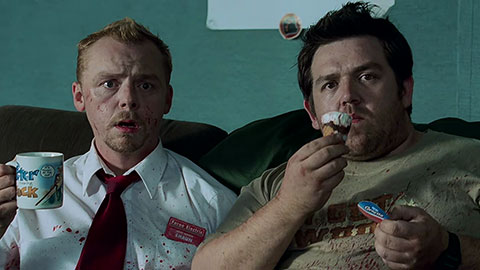Can you describe the main features of this image for me? In this image, we see a scene from the movie "Shaun of the Dead" featuring characters portrayed by actors Simon Pegg and Nick Frost. Simon Pegg's character, Shaun, is seen on the left, dressed in a white shirt with a red tie, and a name tag labeled "Shaun". His face and shirt are splattered with blood, indicating a recent altercation. On the right, Nick Frost's character, Ed, is wearing a brown shirt and is holding a mug that says "I Love My Job" in one hand and a partially eaten ice cream cone in the other. Both characters are seated on a green couch and appear shocked or surprised by something off-screen. This image captures a moment of comedic horror, reflective of the movie's genre. 